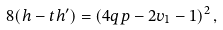Convert formula to latex. <formula><loc_0><loc_0><loc_500><loc_500>8 ( h - t h ^ { \prime } ) = \left ( 4 q p - 2 v _ { 1 } - 1 \right ) ^ { 2 } ,</formula> 